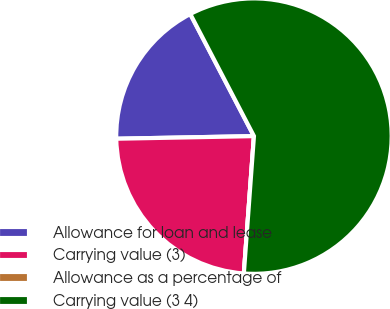Convert chart to OTSL. <chart><loc_0><loc_0><loc_500><loc_500><pie_chart><fcel>Allowance for loan and lease<fcel>Carrying value (3)<fcel>Allowance as a percentage of<fcel>Carrying value (3 4)<nl><fcel>17.65%<fcel>23.53%<fcel>0.0%<fcel>58.82%<nl></chart> 